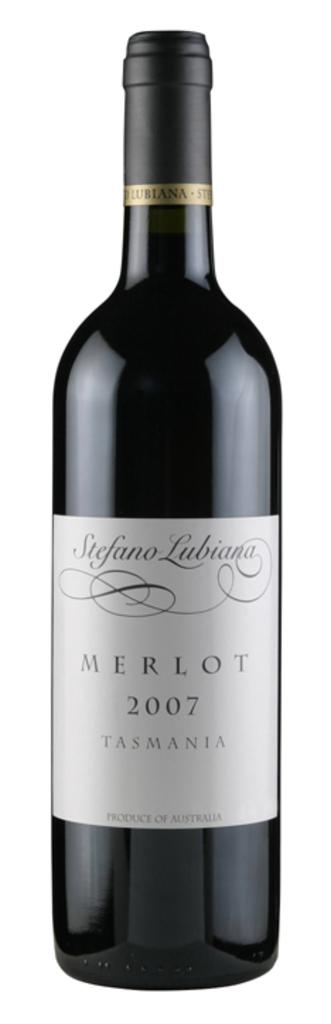<image>
Offer a succinct explanation of the picture presented. Stefano Lubiana merlot tasmania wine that is unopened 